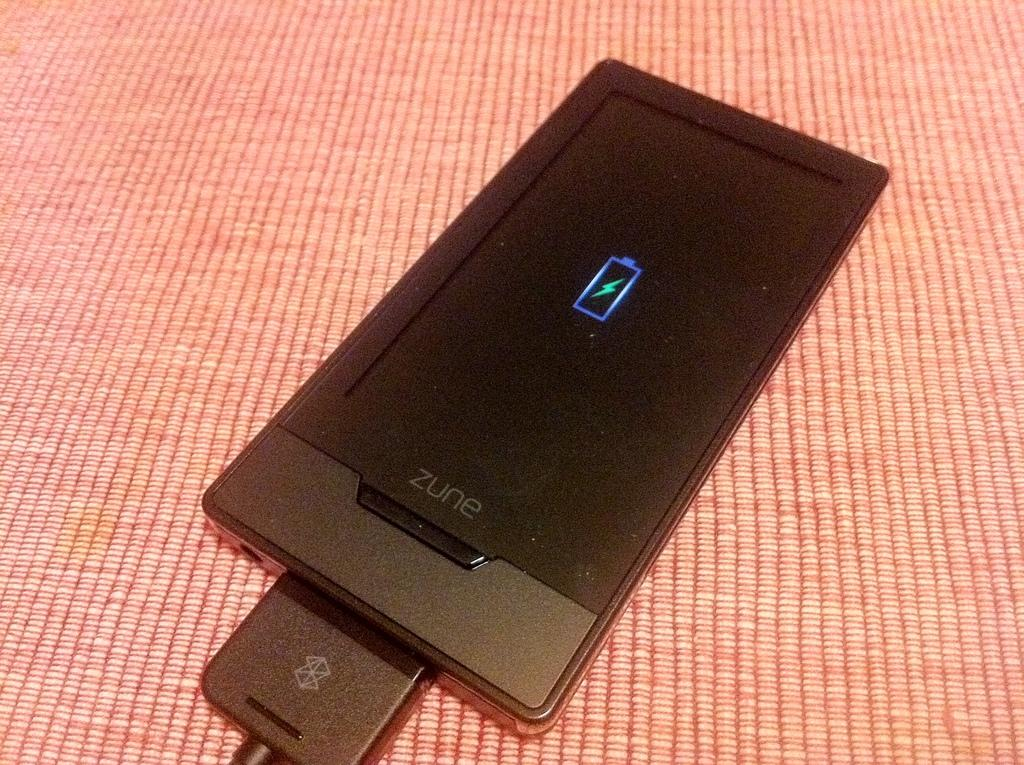<image>
Render a clear and concise summary of the photo. A black Zune that is off and charging. 